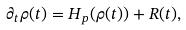<formula> <loc_0><loc_0><loc_500><loc_500>\partial _ { t } \rho ( t ) = H _ { p } ( \rho ( t ) ) + R ( t ) ,</formula> 